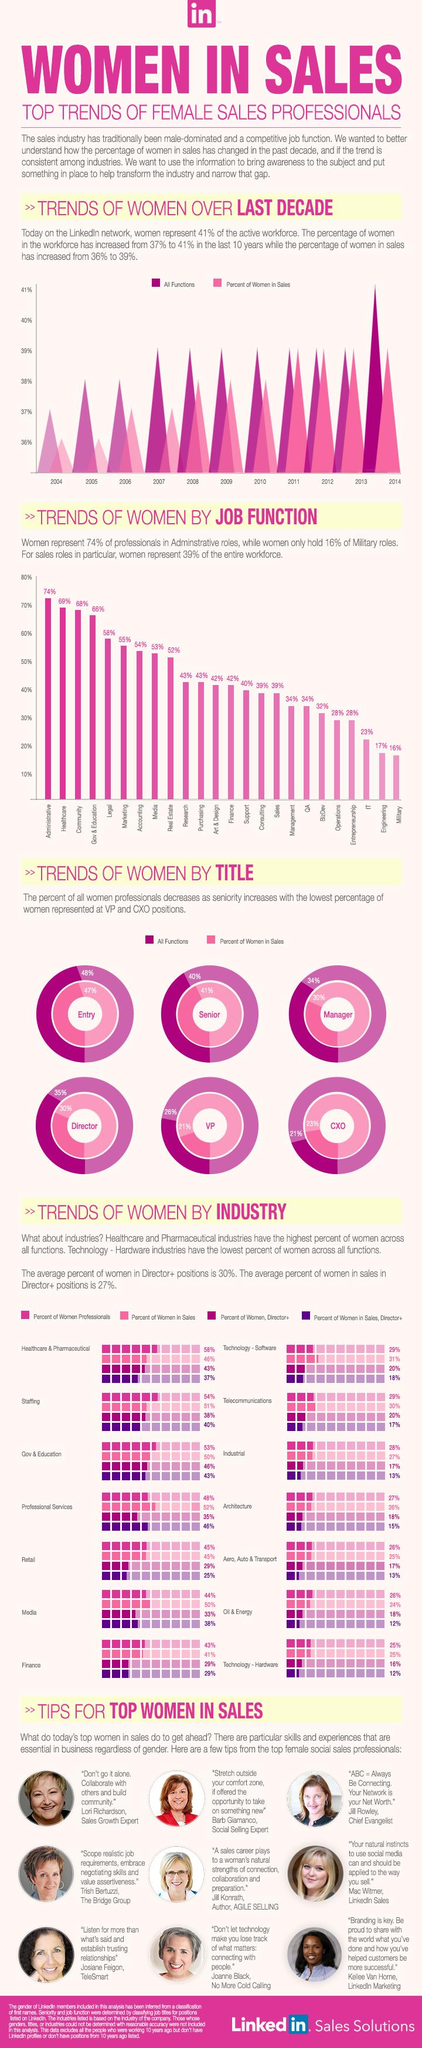Give some essential details in this illustration. According to the data, the majority of women are entering the job functions of research and purchasing. According to a recent survey, only 24% of sales professionals in the oil and energy industry are women. From 2011 to 2013, the percentage of women in sales was 39%. According to the given information, the total percentage of women in VP and CXO roles is 44%. In the field of architecture, only 27% of professionals are women. 